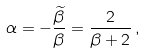<formula> <loc_0><loc_0><loc_500><loc_500>\alpha = - \frac { \widetilde { \beta } } { \beta } = \frac { 2 } { \beta + 2 } \, ,</formula> 